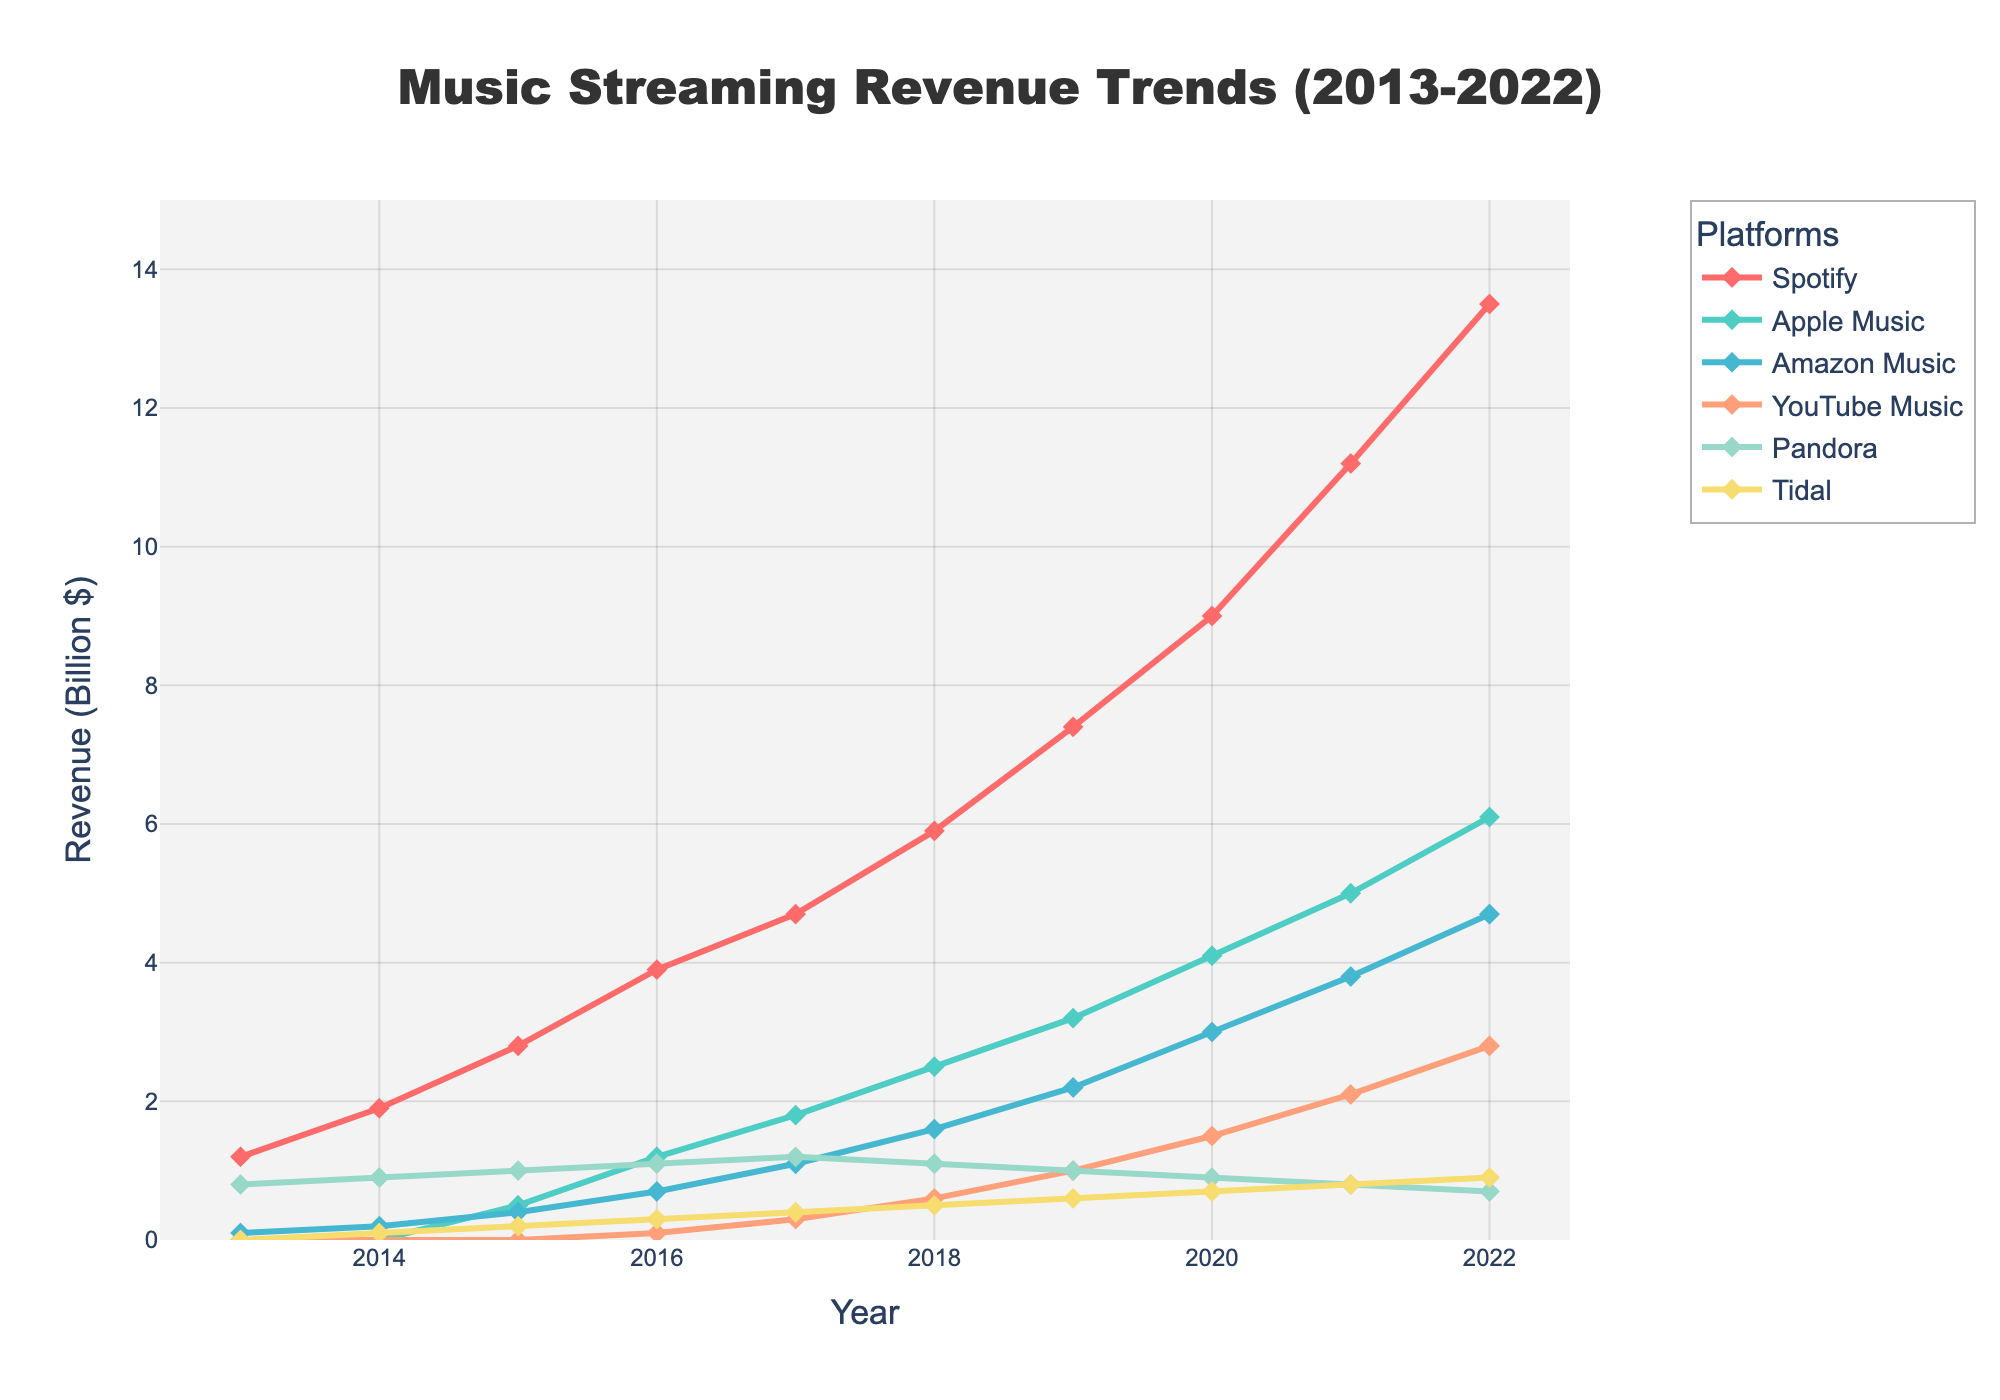What platform had the highest revenue in 2016? The figure shows the revenue trend lines for different platforms. In 2016, Spotify's line is the highest on the y-axis.
Answer: Spotify Compare the revenue of Spotify and Apple Music in 2020. Which one generated more revenue and by how much? According to the figure, in 2020, Spotify's revenue is 9 billion while Apple Music's is 4.1 billion. The difference is 9 - 4.1 = 4.9 billion.
Answer: Spotify, 4.9 billion more What's the total revenue of Amazon Music from 2013 to 2018? Summing up the revenue values for Amazon Music from 2013 to 2018: 0.1 (2013) + 0.2 (2014) + 0.4 (2015) + 0.7 (2016) + 1.1 (2017) + 1.6 (2018) = 4.1 billion.
Answer: 4.1 billion Which platforms saw an increase in revenue every year from 2013 to 2022? By examining the trend lines, Spotify and Apple Music show a steady upward trend each year without any declines.
Answer: Spotify and Apple Music In which year did YouTube Music surpass Pandora in revenue? Looking at the crossing points of lines, YouTube Music's revenue line surpasses Pandora's revenue line in the year 2018.
Answer: 2018 Compare the growth in revenue between Tidal and Pandora from 2013 to 2022. Tidal’s revenue grew from 0 in 2013 to 0.9 in 2022, while Pandora’s revenue went from 0.8 in 2013 to 0.7 in 2022, a decrease.
Answer: Tidal grew, Pandora decreased What is the average revenue of YouTube Music from 2017 to 2022? Sum the revenue values for YouTube Music from 2017 to 2022 then divide by the number of years: (0.3 + 0.6 + 1.0 + 1.5 + 2.1 + 2.8) / 6 = 1.38 billion.
Answer: 1.38 billion Which platform had the smallest revenue in 2019? In 2019, Tidal had the smallest revenue as its line is lowest on the y-axis, indicating 0.6 billion.
Answer: Tidal How much did Spotify’s revenue increase from 2019 to 2022? Spotify's revenue in 2019 was 7.4 billion, and in 2022 it was 13.5 billion. The increase is 13.5 - 7.4 = 6.1 billion.
Answer: 6.1 billion In which years did Amazon Music's revenue double compared to the previous year? From 2018 to 2019, Amazon Music’s revenue went from 1.6 to 2.2 (less than double). From 2019 to 2020, it went from 2.2 to 3.0 (more than double). There are no other years of doubling.
Answer: 2019 to 2020 